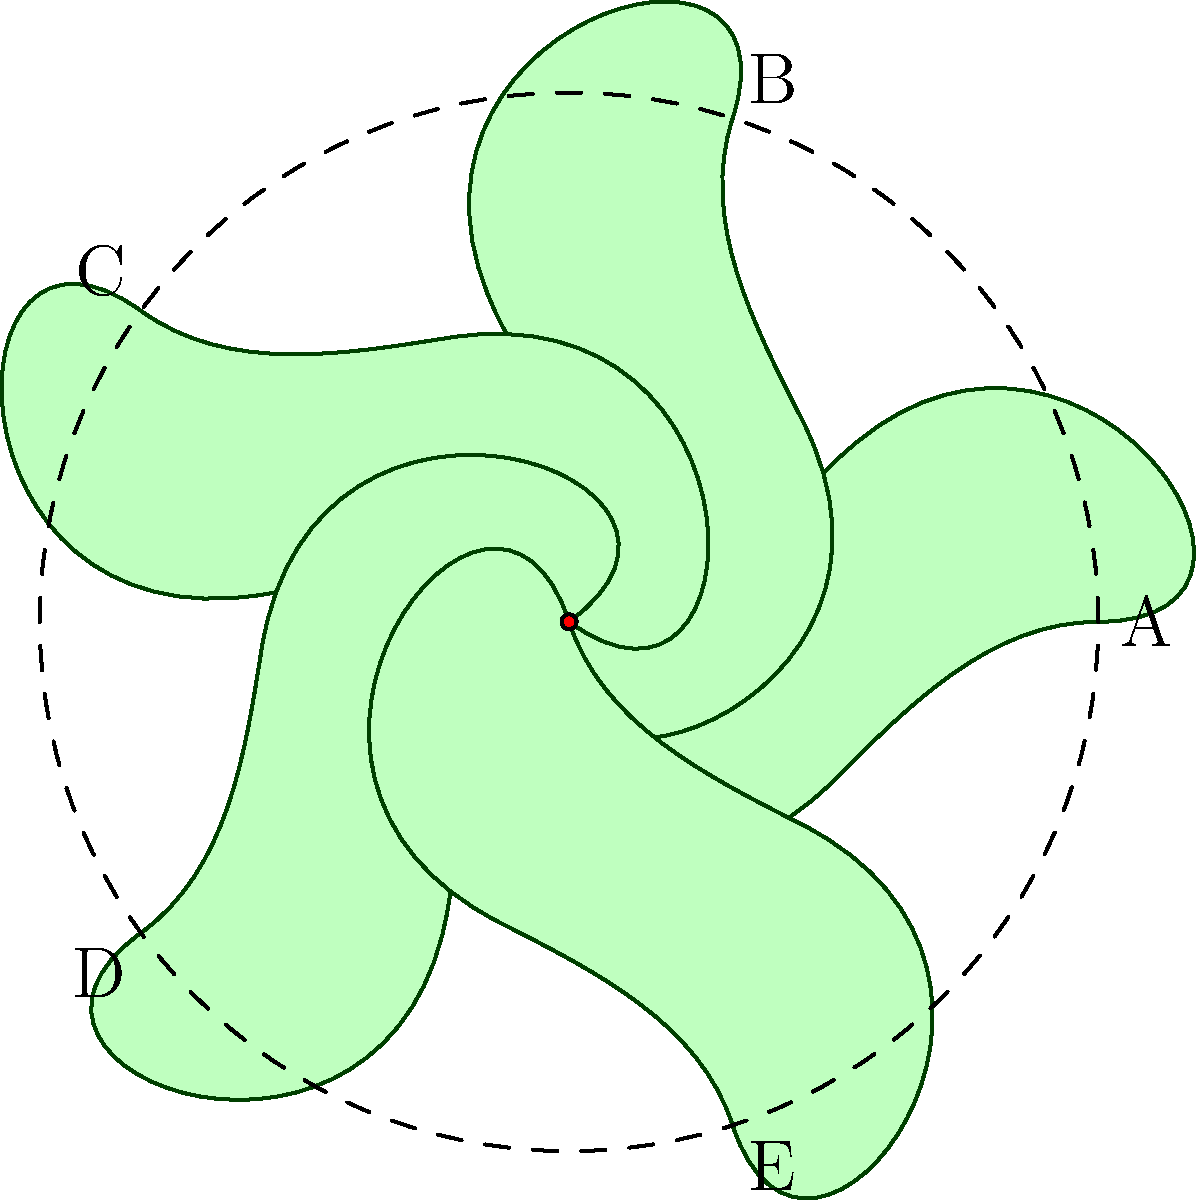A unique flower species found near your remote cabin exhibits perfect radial symmetry. The flower has 5 identical petals arranged as shown in the diagram. If the flower is rotated clockwise by $72^\circ$ around its center, which petal will occupy the position initially held by petal A? To solve this problem, we need to understand the concept of rotational symmetry and apply it to the given flower diagram:

1. The flower has 5 identical petals arranged in a circular pattern.
2. The angle between each petal is $360^\circ \div 5 = 72^\circ$.
3. The petals are labeled A, B, C, D, and E in a clockwise direction.
4. A clockwise rotation of $72^\circ$ is equivalent to moving one position in the clockwise direction.
5. Starting from petal A and moving one position clockwise, we arrive at petal E.

Therefore, after a clockwise rotation of $72^\circ$, petal E will occupy the position initially held by petal A.
Answer: E 